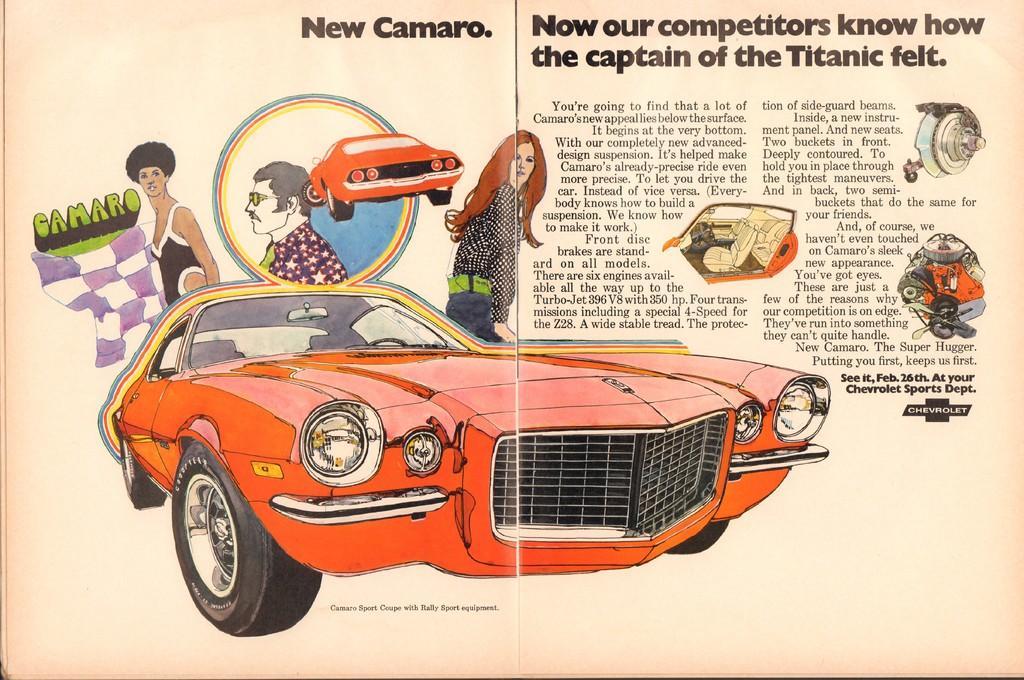Describe this image in one or two sentences. In this image there is a paper and on the paper there is the image of cars and persons and there are some text written on the paper. 